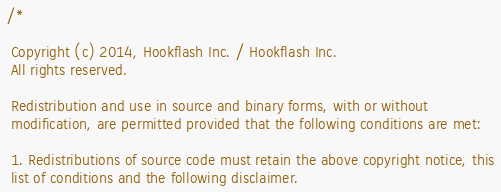Convert code to text. <code><loc_0><loc_0><loc_500><loc_500><_C_>/*

 Copyright (c) 2014, Hookflash Inc. / Hookflash Inc.
 All rights reserved.

 Redistribution and use in source and binary forms, with or without
 modification, are permitted provided that the following conditions are met:

 1. Redistributions of source code must retain the above copyright notice, this
 list of conditions and the following disclaimer.</code> 